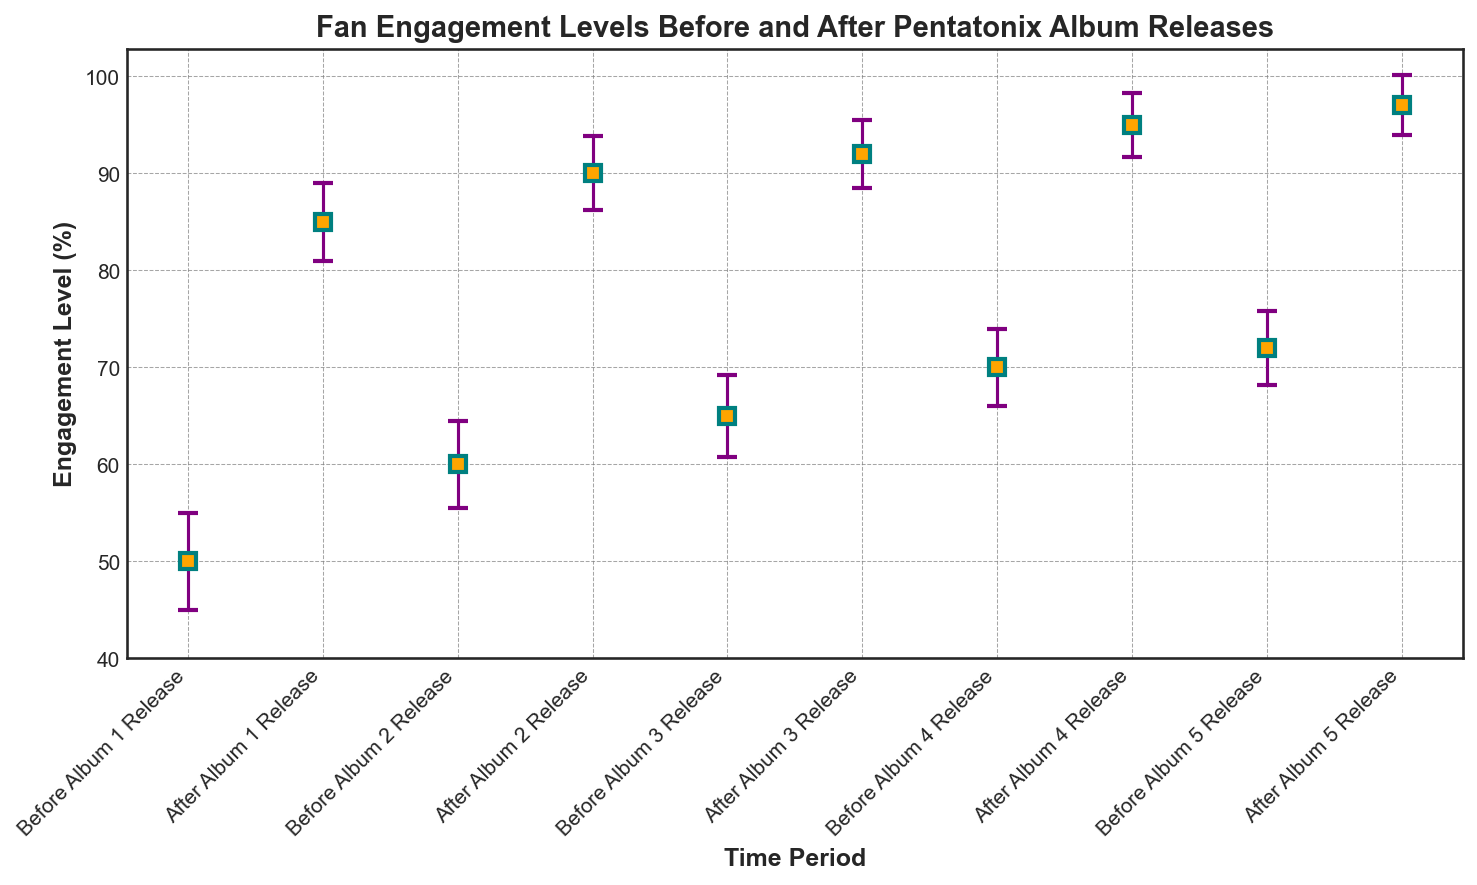What is the highest engagement level recorded in the figure? The highest engagement level can be seen at the peak of the vertical markers (error bars) after the album releases. Identifying the tallest marker, which is after Album 5, shows an engagement level of 97%.
Answer: 97% How does the engagement level after Album 2 release compare to the engagement level before Album 4 release? By comparing the markers for 'After Album 2 Release' and 'Before Album 4 Release,' we see the engagement levels are 90% and 70%, respectively. 90% is greater than 70%.
Answer: After Album 2 release has a higher engagement level than before Album 4 release What's the average engagement level after the album releases? Sum the engagement levels after each album release (85 + 90 + 92 + 95 + 97) and divide by the number of data points (5). The total is 459, and the average is 459/5.
Answer: 91.8 Which album release shows the smallest margin of error, and what is its value? Look for the smallest length of the error bars, which corresponds to 'After Album 5 Release' with a margin of error of 3.1.
Answer: Album 5 release (3.1) What is the overall increase in engagement level from before Album 1 release to after Album 5 release? Subtract the engagement level before Album 1 release (50) from the engagement level after Album 5 release (97). The difference is 97 - 50.
Answer: 47 What is the difference in margin of error between before and after Album 3 release? Subtract the margin of error before Album 3 release (4.2) from the margin of error after Album 3 release (3.5). The difference is 4.2 - 3.5.
Answer: 0.7 How does the engagement level after Album 4 release compare to the engagement level before Album 2 release? Comparing the markers, 'After Album 4 Release' shows 95% while 'Before Album 2 Release' shows 60%. 95% is greater than 60%.
Answer: After Album 4 release is higher than before Album 2 release What is the average margin of error for the engagement levels before album releases? Calculate the sum of the margins of error for the periods before the album releases (5 + 4.5 + 4.2 + 4 + 3.8) and divide by 5. The total is 21.5, and the average is 21.5/5.
Answer: 4.3 